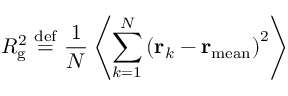Convert formula to latex. <formula><loc_0><loc_0><loc_500><loc_500>R _ { g } ^ { 2 } \ { \stackrel { d e f } { = } } \ { \frac { 1 } { N } } \left \langle \sum _ { k = 1 } ^ { N } \left ( r _ { k } - r _ { m e a n } \right ) ^ { 2 } \right \rangle</formula> 